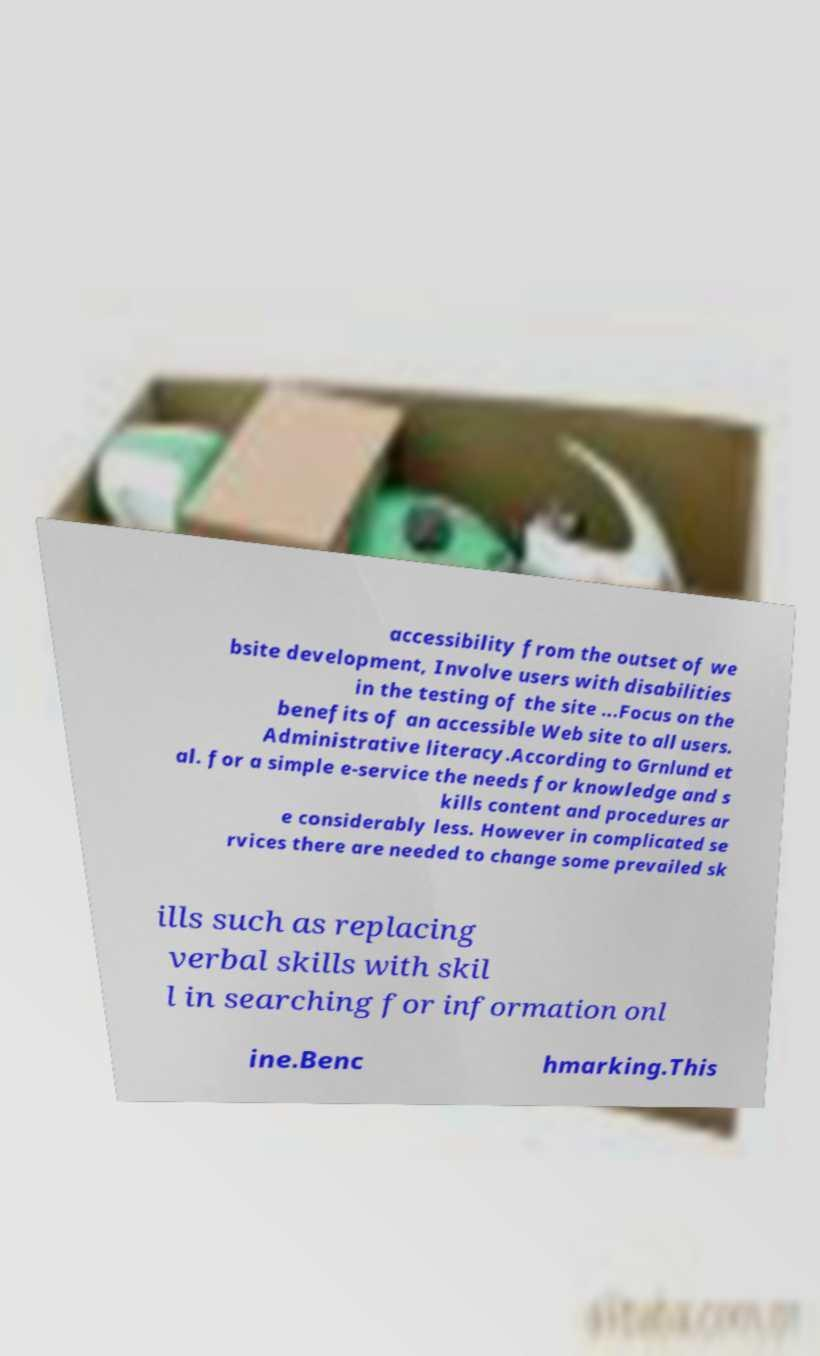For documentation purposes, I need the text within this image transcribed. Could you provide that? accessibility from the outset of we bsite development, Involve users with disabilities in the testing of the site ...Focus on the benefits of an accessible Web site to all users. Administrative literacy.According to Grnlund et al. for a simple e-service the needs for knowledge and s kills content and procedures ar e considerably less. However in complicated se rvices there are needed to change some prevailed sk ills such as replacing verbal skills with skil l in searching for information onl ine.Benc hmarking.This 